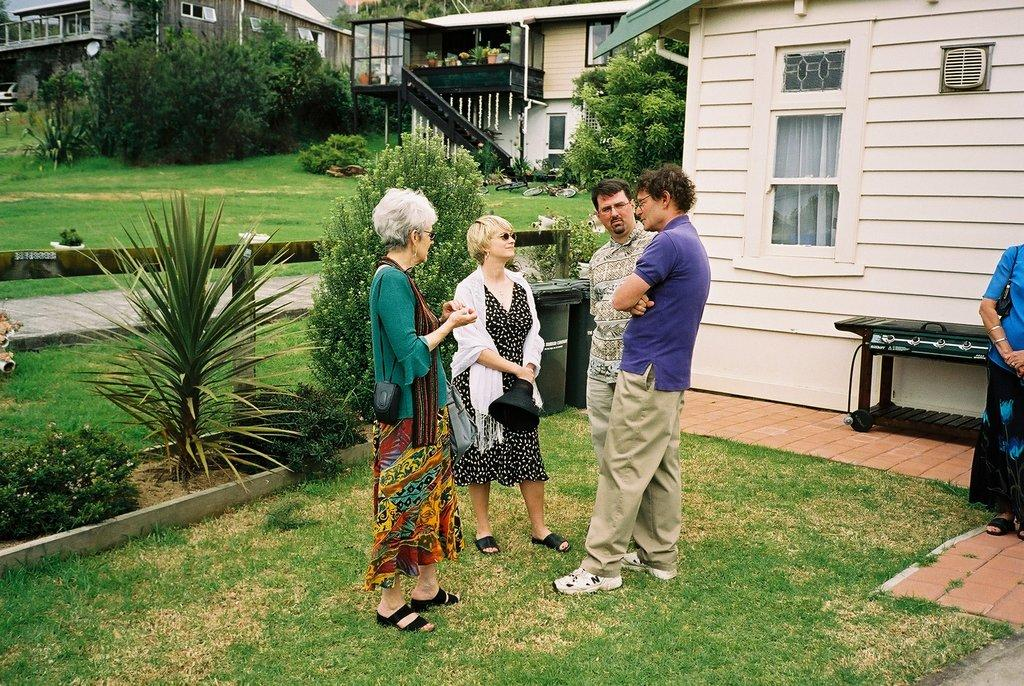What are the persons in the image doing? The persons in the image are on the grass. What can be seen in the background of the image? In the background of the image, there are houses, trees, grass, plants, and a car. How many types of vegetation are visible in the background? There are three types of vegetation visible in the background: trees, grass, and plants. What type of crack is present in the image? There is no crack present in the image. How are the persons using a fork in the image? There is no fork present in the image. 